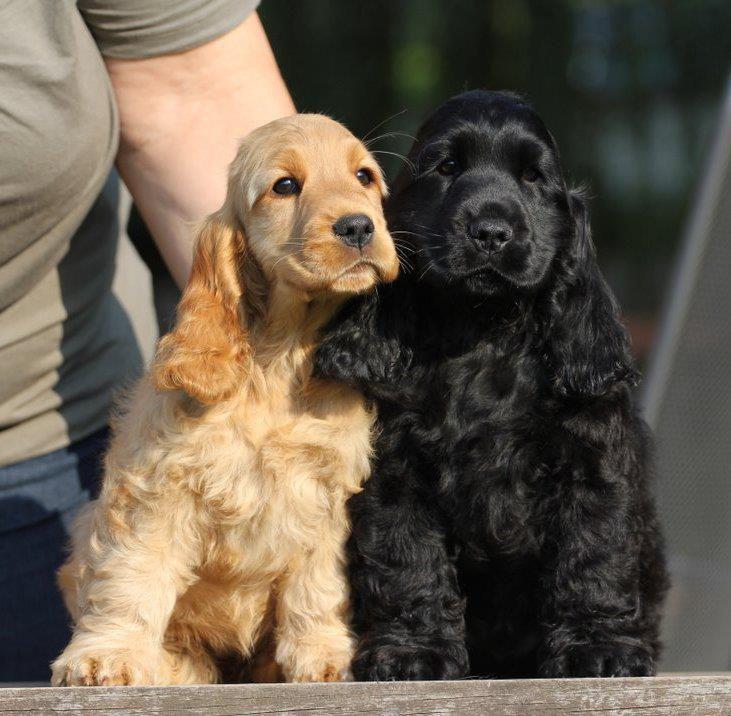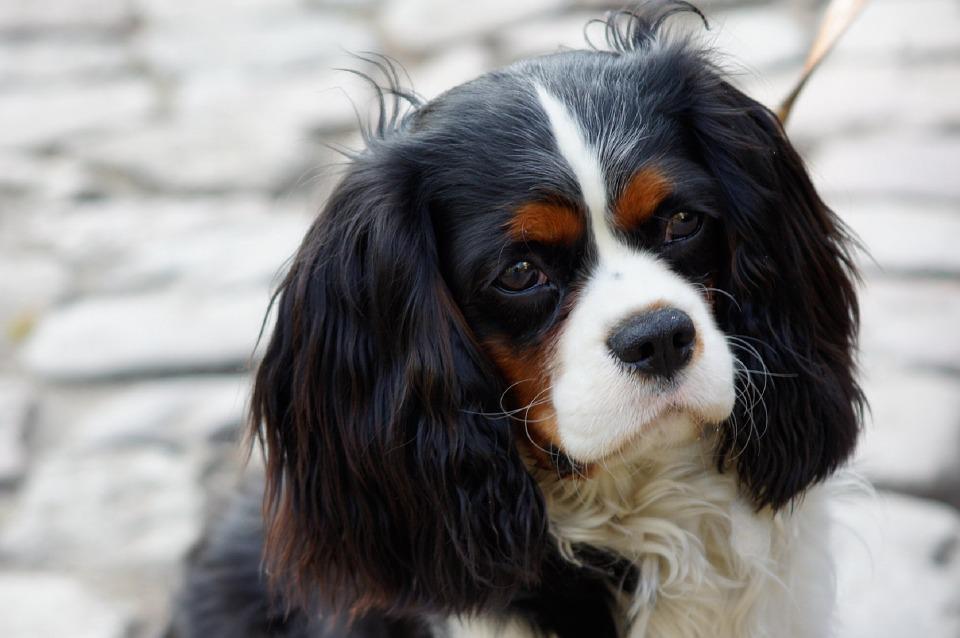The first image is the image on the left, the second image is the image on the right. Given the left and right images, does the statement "An all black puppy and an all brown puppy are next to each other." hold true? Answer yes or no. Yes. The first image is the image on the left, the second image is the image on the right. Considering the images on both sides, is "There is a tan dog beside a black dog in one of the images." valid? Answer yes or no. Yes. 